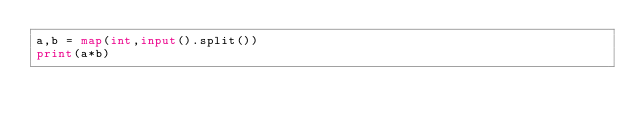<code> <loc_0><loc_0><loc_500><loc_500><_Python_>a,b = map(int,input().split())
print(a*b)</code> 